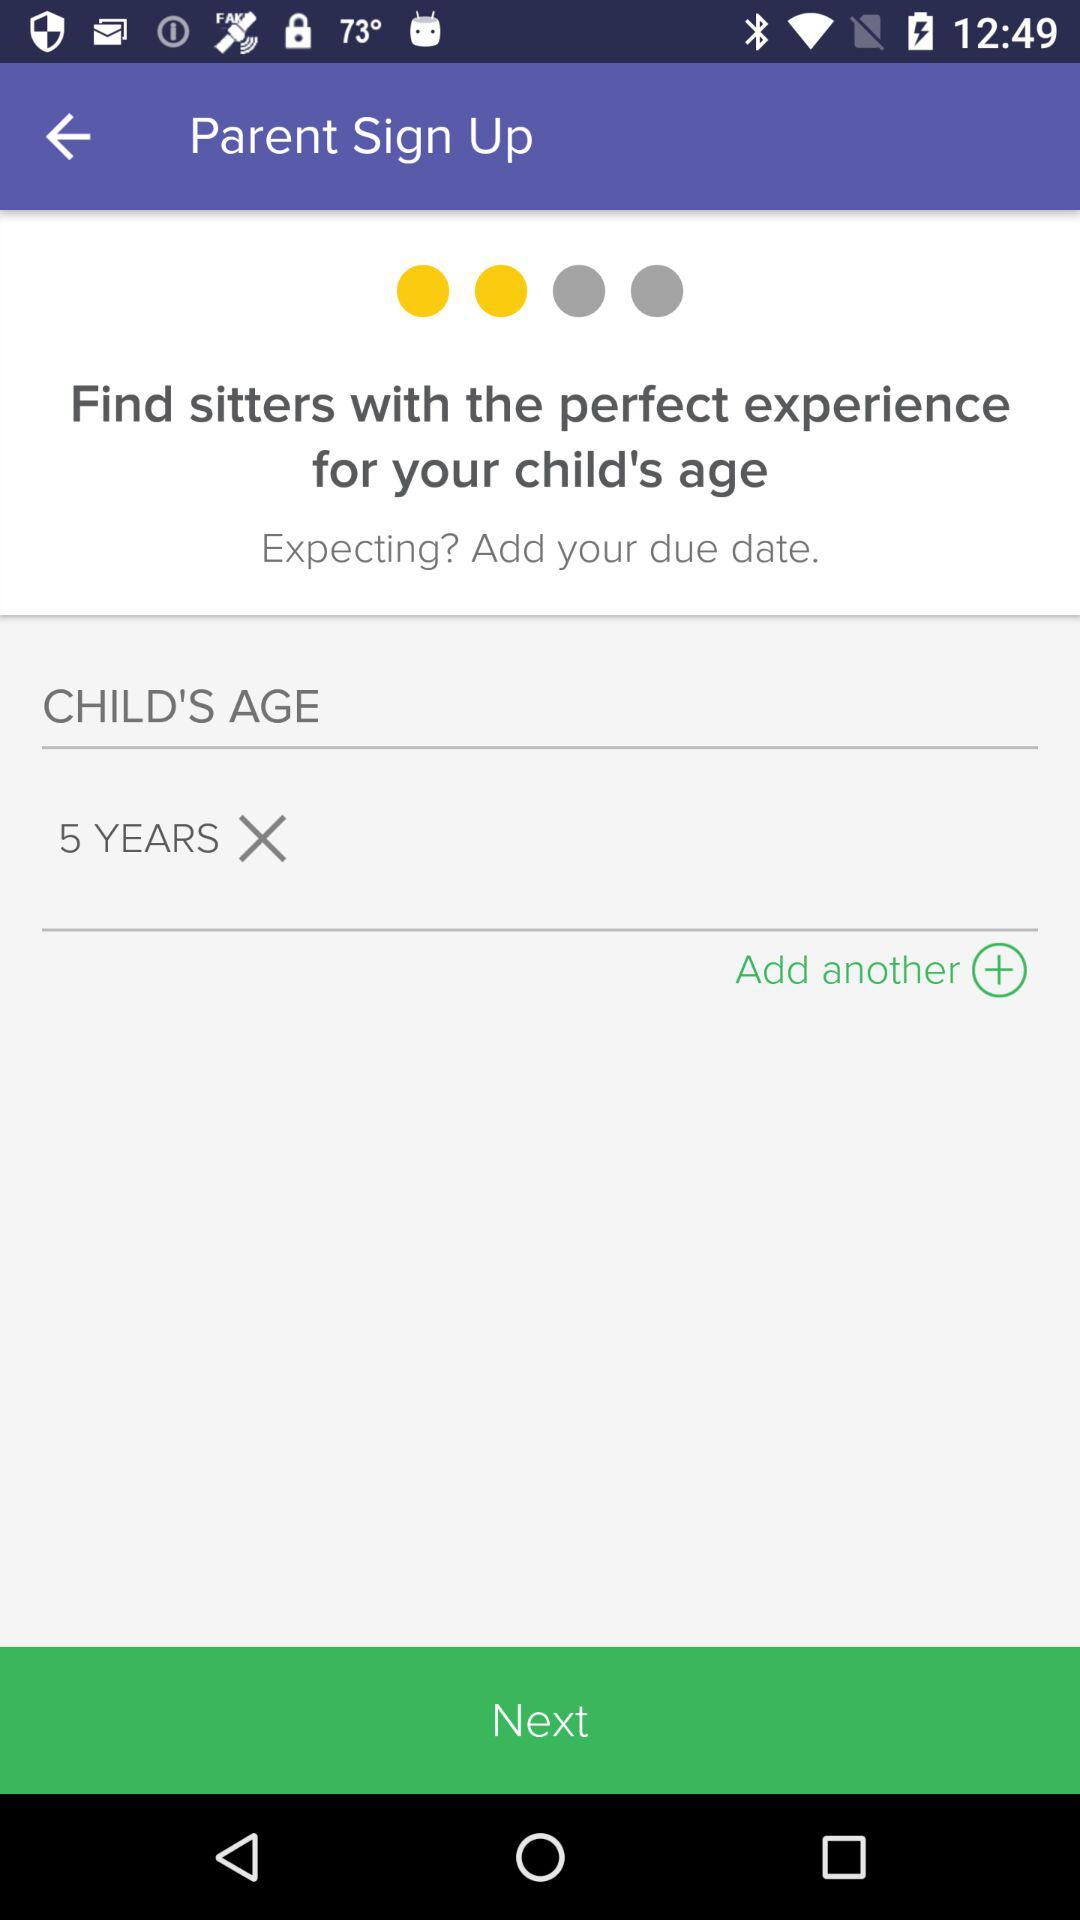What is the child's age? The child is 5 years old. 